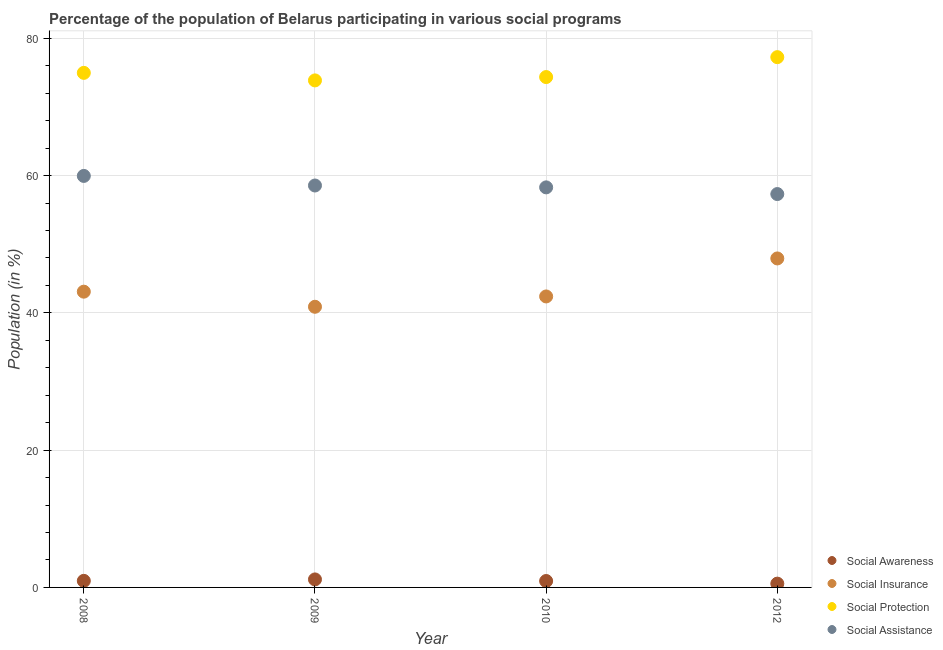What is the participation of population in social protection programs in 2009?
Keep it short and to the point. 73.86. Across all years, what is the maximum participation of population in social protection programs?
Keep it short and to the point. 77.25. Across all years, what is the minimum participation of population in social assistance programs?
Keep it short and to the point. 57.3. In which year was the participation of population in social assistance programs maximum?
Your answer should be very brief. 2008. What is the total participation of population in social protection programs in the graph?
Your answer should be very brief. 300.42. What is the difference between the participation of population in social protection programs in 2010 and that in 2012?
Offer a terse response. -2.9. What is the difference between the participation of population in social awareness programs in 2010 and the participation of population in social insurance programs in 2008?
Your answer should be very brief. -42.15. What is the average participation of population in social protection programs per year?
Offer a very short reply. 75.11. In the year 2009, what is the difference between the participation of population in social protection programs and participation of population in social insurance programs?
Ensure brevity in your answer.  32.98. What is the ratio of the participation of population in social protection programs in 2009 to that in 2012?
Offer a very short reply. 0.96. Is the participation of population in social insurance programs in 2008 less than that in 2010?
Give a very brief answer. No. What is the difference between the highest and the second highest participation of population in social protection programs?
Provide a short and direct response. 2.29. What is the difference between the highest and the lowest participation of population in social insurance programs?
Offer a terse response. 7.04. Is the sum of the participation of population in social protection programs in 2009 and 2012 greater than the maximum participation of population in social assistance programs across all years?
Offer a very short reply. Yes. Is it the case that in every year, the sum of the participation of population in social insurance programs and participation of population in social assistance programs is greater than the sum of participation of population in social awareness programs and participation of population in social protection programs?
Ensure brevity in your answer.  Yes. Is it the case that in every year, the sum of the participation of population in social awareness programs and participation of population in social insurance programs is greater than the participation of population in social protection programs?
Provide a succinct answer. No. Is the participation of population in social assistance programs strictly greater than the participation of population in social insurance programs over the years?
Your answer should be very brief. Yes. Is the participation of population in social insurance programs strictly less than the participation of population in social protection programs over the years?
Offer a very short reply. Yes. How many years are there in the graph?
Offer a terse response. 4. Are the values on the major ticks of Y-axis written in scientific E-notation?
Provide a succinct answer. No. Does the graph contain any zero values?
Offer a very short reply. No. Where does the legend appear in the graph?
Offer a very short reply. Bottom right. What is the title of the graph?
Provide a short and direct response. Percentage of the population of Belarus participating in various social programs . What is the Population (in %) in Social Awareness in 2008?
Provide a short and direct response. 0.96. What is the Population (in %) in Social Insurance in 2008?
Make the answer very short. 43.09. What is the Population (in %) in Social Protection in 2008?
Give a very brief answer. 74.96. What is the Population (in %) of Social Assistance in 2008?
Keep it short and to the point. 59.95. What is the Population (in %) in Social Awareness in 2009?
Make the answer very short. 1.17. What is the Population (in %) of Social Insurance in 2009?
Keep it short and to the point. 40.89. What is the Population (in %) in Social Protection in 2009?
Offer a very short reply. 73.86. What is the Population (in %) in Social Assistance in 2009?
Keep it short and to the point. 58.55. What is the Population (in %) of Social Awareness in 2010?
Ensure brevity in your answer.  0.93. What is the Population (in %) in Social Insurance in 2010?
Your response must be concise. 42.39. What is the Population (in %) in Social Protection in 2010?
Ensure brevity in your answer.  74.35. What is the Population (in %) of Social Assistance in 2010?
Provide a short and direct response. 58.28. What is the Population (in %) of Social Awareness in 2012?
Make the answer very short. 0.55. What is the Population (in %) in Social Insurance in 2012?
Give a very brief answer. 47.93. What is the Population (in %) in Social Protection in 2012?
Offer a terse response. 77.25. What is the Population (in %) of Social Assistance in 2012?
Offer a very short reply. 57.3. Across all years, what is the maximum Population (in %) in Social Awareness?
Keep it short and to the point. 1.17. Across all years, what is the maximum Population (in %) of Social Insurance?
Make the answer very short. 47.93. Across all years, what is the maximum Population (in %) in Social Protection?
Provide a short and direct response. 77.25. Across all years, what is the maximum Population (in %) in Social Assistance?
Ensure brevity in your answer.  59.95. Across all years, what is the minimum Population (in %) in Social Awareness?
Your answer should be very brief. 0.55. Across all years, what is the minimum Population (in %) of Social Insurance?
Keep it short and to the point. 40.89. Across all years, what is the minimum Population (in %) of Social Protection?
Make the answer very short. 73.86. Across all years, what is the minimum Population (in %) of Social Assistance?
Ensure brevity in your answer.  57.3. What is the total Population (in %) in Social Awareness in the graph?
Provide a succinct answer. 3.61. What is the total Population (in %) in Social Insurance in the graph?
Your answer should be compact. 174.29. What is the total Population (in %) of Social Protection in the graph?
Give a very brief answer. 300.42. What is the total Population (in %) in Social Assistance in the graph?
Give a very brief answer. 234.08. What is the difference between the Population (in %) in Social Awareness in 2008 and that in 2009?
Your answer should be compact. -0.21. What is the difference between the Population (in %) of Social Insurance in 2008 and that in 2009?
Your answer should be very brief. 2.2. What is the difference between the Population (in %) of Social Protection in 2008 and that in 2009?
Offer a very short reply. 1.1. What is the difference between the Population (in %) of Social Assistance in 2008 and that in 2009?
Keep it short and to the point. 1.4. What is the difference between the Population (in %) of Social Awareness in 2008 and that in 2010?
Provide a succinct answer. 0.02. What is the difference between the Population (in %) in Social Insurance in 2008 and that in 2010?
Make the answer very short. 0.7. What is the difference between the Population (in %) in Social Protection in 2008 and that in 2010?
Offer a terse response. 0.61. What is the difference between the Population (in %) in Social Assistance in 2008 and that in 2010?
Offer a terse response. 1.67. What is the difference between the Population (in %) of Social Awareness in 2008 and that in 2012?
Your answer should be compact. 0.4. What is the difference between the Population (in %) of Social Insurance in 2008 and that in 2012?
Offer a very short reply. -4.84. What is the difference between the Population (in %) in Social Protection in 2008 and that in 2012?
Give a very brief answer. -2.29. What is the difference between the Population (in %) in Social Assistance in 2008 and that in 2012?
Keep it short and to the point. 2.64. What is the difference between the Population (in %) in Social Awareness in 2009 and that in 2010?
Your answer should be compact. 0.23. What is the difference between the Population (in %) of Social Insurance in 2009 and that in 2010?
Your answer should be compact. -1.5. What is the difference between the Population (in %) in Social Protection in 2009 and that in 2010?
Provide a short and direct response. -0.49. What is the difference between the Population (in %) in Social Assistance in 2009 and that in 2010?
Ensure brevity in your answer.  0.27. What is the difference between the Population (in %) in Social Awareness in 2009 and that in 2012?
Make the answer very short. 0.61. What is the difference between the Population (in %) in Social Insurance in 2009 and that in 2012?
Your answer should be very brief. -7.04. What is the difference between the Population (in %) of Social Protection in 2009 and that in 2012?
Your answer should be very brief. -3.39. What is the difference between the Population (in %) in Social Assistance in 2009 and that in 2012?
Provide a succinct answer. 1.25. What is the difference between the Population (in %) in Social Awareness in 2010 and that in 2012?
Provide a succinct answer. 0.38. What is the difference between the Population (in %) in Social Insurance in 2010 and that in 2012?
Provide a succinct answer. -5.54. What is the difference between the Population (in %) in Social Protection in 2010 and that in 2012?
Your answer should be very brief. -2.9. What is the difference between the Population (in %) in Social Assistance in 2010 and that in 2012?
Give a very brief answer. 0.97. What is the difference between the Population (in %) of Social Awareness in 2008 and the Population (in %) of Social Insurance in 2009?
Your answer should be compact. -39.93. What is the difference between the Population (in %) of Social Awareness in 2008 and the Population (in %) of Social Protection in 2009?
Provide a succinct answer. -72.9. What is the difference between the Population (in %) of Social Awareness in 2008 and the Population (in %) of Social Assistance in 2009?
Your answer should be compact. -57.59. What is the difference between the Population (in %) in Social Insurance in 2008 and the Population (in %) in Social Protection in 2009?
Provide a short and direct response. -30.78. What is the difference between the Population (in %) in Social Insurance in 2008 and the Population (in %) in Social Assistance in 2009?
Offer a very short reply. -15.47. What is the difference between the Population (in %) in Social Protection in 2008 and the Population (in %) in Social Assistance in 2009?
Offer a very short reply. 16.41. What is the difference between the Population (in %) in Social Awareness in 2008 and the Population (in %) in Social Insurance in 2010?
Your answer should be compact. -41.43. What is the difference between the Population (in %) of Social Awareness in 2008 and the Population (in %) of Social Protection in 2010?
Make the answer very short. -73.39. What is the difference between the Population (in %) of Social Awareness in 2008 and the Population (in %) of Social Assistance in 2010?
Offer a terse response. -57.32. What is the difference between the Population (in %) in Social Insurance in 2008 and the Population (in %) in Social Protection in 2010?
Ensure brevity in your answer.  -31.26. What is the difference between the Population (in %) in Social Insurance in 2008 and the Population (in %) in Social Assistance in 2010?
Your answer should be compact. -15.19. What is the difference between the Population (in %) of Social Protection in 2008 and the Population (in %) of Social Assistance in 2010?
Ensure brevity in your answer.  16.68. What is the difference between the Population (in %) in Social Awareness in 2008 and the Population (in %) in Social Insurance in 2012?
Your answer should be very brief. -46.97. What is the difference between the Population (in %) of Social Awareness in 2008 and the Population (in %) of Social Protection in 2012?
Offer a very short reply. -76.29. What is the difference between the Population (in %) of Social Awareness in 2008 and the Population (in %) of Social Assistance in 2012?
Keep it short and to the point. -56.35. What is the difference between the Population (in %) in Social Insurance in 2008 and the Population (in %) in Social Protection in 2012?
Your answer should be compact. -34.16. What is the difference between the Population (in %) of Social Insurance in 2008 and the Population (in %) of Social Assistance in 2012?
Your answer should be very brief. -14.22. What is the difference between the Population (in %) of Social Protection in 2008 and the Population (in %) of Social Assistance in 2012?
Your answer should be compact. 17.66. What is the difference between the Population (in %) in Social Awareness in 2009 and the Population (in %) in Social Insurance in 2010?
Provide a short and direct response. -41.22. What is the difference between the Population (in %) in Social Awareness in 2009 and the Population (in %) in Social Protection in 2010?
Keep it short and to the point. -73.18. What is the difference between the Population (in %) of Social Awareness in 2009 and the Population (in %) of Social Assistance in 2010?
Ensure brevity in your answer.  -57.11. What is the difference between the Population (in %) in Social Insurance in 2009 and the Population (in %) in Social Protection in 2010?
Ensure brevity in your answer.  -33.47. What is the difference between the Population (in %) of Social Insurance in 2009 and the Population (in %) of Social Assistance in 2010?
Your answer should be very brief. -17.39. What is the difference between the Population (in %) in Social Protection in 2009 and the Population (in %) in Social Assistance in 2010?
Your answer should be very brief. 15.58. What is the difference between the Population (in %) in Social Awareness in 2009 and the Population (in %) in Social Insurance in 2012?
Provide a succinct answer. -46.76. What is the difference between the Population (in %) of Social Awareness in 2009 and the Population (in %) of Social Protection in 2012?
Your answer should be very brief. -76.08. What is the difference between the Population (in %) in Social Awareness in 2009 and the Population (in %) in Social Assistance in 2012?
Keep it short and to the point. -56.14. What is the difference between the Population (in %) of Social Insurance in 2009 and the Population (in %) of Social Protection in 2012?
Offer a terse response. -36.37. What is the difference between the Population (in %) of Social Insurance in 2009 and the Population (in %) of Social Assistance in 2012?
Your answer should be very brief. -16.42. What is the difference between the Population (in %) in Social Protection in 2009 and the Population (in %) in Social Assistance in 2012?
Provide a short and direct response. 16.56. What is the difference between the Population (in %) in Social Awareness in 2010 and the Population (in %) in Social Insurance in 2012?
Your answer should be compact. -46.99. What is the difference between the Population (in %) in Social Awareness in 2010 and the Population (in %) in Social Protection in 2012?
Give a very brief answer. -76.32. What is the difference between the Population (in %) in Social Awareness in 2010 and the Population (in %) in Social Assistance in 2012?
Make the answer very short. -56.37. What is the difference between the Population (in %) in Social Insurance in 2010 and the Population (in %) in Social Protection in 2012?
Provide a short and direct response. -34.86. What is the difference between the Population (in %) of Social Insurance in 2010 and the Population (in %) of Social Assistance in 2012?
Your answer should be compact. -14.92. What is the difference between the Population (in %) of Social Protection in 2010 and the Population (in %) of Social Assistance in 2012?
Keep it short and to the point. 17.05. What is the average Population (in %) of Social Awareness per year?
Give a very brief answer. 0.9. What is the average Population (in %) of Social Insurance per year?
Provide a succinct answer. 43.57. What is the average Population (in %) of Social Protection per year?
Offer a very short reply. 75.11. What is the average Population (in %) in Social Assistance per year?
Ensure brevity in your answer.  58.52. In the year 2008, what is the difference between the Population (in %) of Social Awareness and Population (in %) of Social Insurance?
Your response must be concise. -42.13. In the year 2008, what is the difference between the Population (in %) of Social Awareness and Population (in %) of Social Protection?
Your answer should be very brief. -74. In the year 2008, what is the difference between the Population (in %) of Social Awareness and Population (in %) of Social Assistance?
Your response must be concise. -58.99. In the year 2008, what is the difference between the Population (in %) in Social Insurance and Population (in %) in Social Protection?
Your answer should be very brief. -31.88. In the year 2008, what is the difference between the Population (in %) in Social Insurance and Population (in %) in Social Assistance?
Make the answer very short. -16.86. In the year 2008, what is the difference between the Population (in %) in Social Protection and Population (in %) in Social Assistance?
Make the answer very short. 15.01. In the year 2009, what is the difference between the Population (in %) in Social Awareness and Population (in %) in Social Insurance?
Ensure brevity in your answer.  -39.72. In the year 2009, what is the difference between the Population (in %) of Social Awareness and Population (in %) of Social Protection?
Ensure brevity in your answer.  -72.7. In the year 2009, what is the difference between the Population (in %) in Social Awareness and Population (in %) in Social Assistance?
Your answer should be very brief. -57.39. In the year 2009, what is the difference between the Population (in %) of Social Insurance and Population (in %) of Social Protection?
Offer a very short reply. -32.98. In the year 2009, what is the difference between the Population (in %) of Social Insurance and Population (in %) of Social Assistance?
Offer a terse response. -17.67. In the year 2009, what is the difference between the Population (in %) of Social Protection and Population (in %) of Social Assistance?
Make the answer very short. 15.31. In the year 2010, what is the difference between the Population (in %) of Social Awareness and Population (in %) of Social Insurance?
Your response must be concise. -41.46. In the year 2010, what is the difference between the Population (in %) in Social Awareness and Population (in %) in Social Protection?
Make the answer very short. -73.42. In the year 2010, what is the difference between the Population (in %) of Social Awareness and Population (in %) of Social Assistance?
Your answer should be very brief. -57.34. In the year 2010, what is the difference between the Population (in %) in Social Insurance and Population (in %) in Social Protection?
Give a very brief answer. -31.96. In the year 2010, what is the difference between the Population (in %) of Social Insurance and Population (in %) of Social Assistance?
Offer a terse response. -15.89. In the year 2010, what is the difference between the Population (in %) in Social Protection and Population (in %) in Social Assistance?
Make the answer very short. 16.07. In the year 2012, what is the difference between the Population (in %) in Social Awareness and Population (in %) in Social Insurance?
Your answer should be compact. -47.37. In the year 2012, what is the difference between the Population (in %) of Social Awareness and Population (in %) of Social Protection?
Provide a short and direct response. -76.7. In the year 2012, what is the difference between the Population (in %) in Social Awareness and Population (in %) in Social Assistance?
Keep it short and to the point. -56.75. In the year 2012, what is the difference between the Population (in %) of Social Insurance and Population (in %) of Social Protection?
Your answer should be very brief. -29.32. In the year 2012, what is the difference between the Population (in %) in Social Insurance and Population (in %) in Social Assistance?
Make the answer very short. -9.38. In the year 2012, what is the difference between the Population (in %) in Social Protection and Population (in %) in Social Assistance?
Keep it short and to the point. 19.95. What is the ratio of the Population (in %) of Social Awareness in 2008 to that in 2009?
Provide a short and direct response. 0.82. What is the ratio of the Population (in %) of Social Insurance in 2008 to that in 2009?
Give a very brief answer. 1.05. What is the ratio of the Population (in %) of Social Protection in 2008 to that in 2009?
Ensure brevity in your answer.  1.01. What is the ratio of the Population (in %) in Social Assistance in 2008 to that in 2009?
Your answer should be very brief. 1.02. What is the ratio of the Population (in %) in Social Awareness in 2008 to that in 2010?
Your answer should be very brief. 1.02. What is the ratio of the Population (in %) in Social Insurance in 2008 to that in 2010?
Keep it short and to the point. 1.02. What is the ratio of the Population (in %) of Social Protection in 2008 to that in 2010?
Provide a succinct answer. 1.01. What is the ratio of the Population (in %) in Social Assistance in 2008 to that in 2010?
Your answer should be compact. 1.03. What is the ratio of the Population (in %) of Social Awareness in 2008 to that in 2012?
Give a very brief answer. 1.73. What is the ratio of the Population (in %) of Social Insurance in 2008 to that in 2012?
Give a very brief answer. 0.9. What is the ratio of the Population (in %) in Social Protection in 2008 to that in 2012?
Provide a succinct answer. 0.97. What is the ratio of the Population (in %) of Social Assistance in 2008 to that in 2012?
Ensure brevity in your answer.  1.05. What is the ratio of the Population (in %) of Social Awareness in 2009 to that in 2010?
Your answer should be compact. 1.25. What is the ratio of the Population (in %) of Social Insurance in 2009 to that in 2010?
Ensure brevity in your answer.  0.96. What is the ratio of the Population (in %) in Social Protection in 2009 to that in 2010?
Your answer should be compact. 0.99. What is the ratio of the Population (in %) in Social Assistance in 2009 to that in 2010?
Your answer should be compact. 1. What is the ratio of the Population (in %) in Social Awareness in 2009 to that in 2012?
Keep it short and to the point. 2.11. What is the ratio of the Population (in %) of Social Insurance in 2009 to that in 2012?
Ensure brevity in your answer.  0.85. What is the ratio of the Population (in %) of Social Protection in 2009 to that in 2012?
Keep it short and to the point. 0.96. What is the ratio of the Population (in %) of Social Assistance in 2009 to that in 2012?
Your answer should be compact. 1.02. What is the ratio of the Population (in %) in Social Awareness in 2010 to that in 2012?
Give a very brief answer. 1.69. What is the ratio of the Population (in %) in Social Insurance in 2010 to that in 2012?
Your answer should be very brief. 0.88. What is the ratio of the Population (in %) of Social Protection in 2010 to that in 2012?
Your response must be concise. 0.96. What is the difference between the highest and the second highest Population (in %) in Social Awareness?
Provide a succinct answer. 0.21. What is the difference between the highest and the second highest Population (in %) in Social Insurance?
Give a very brief answer. 4.84. What is the difference between the highest and the second highest Population (in %) in Social Protection?
Your answer should be very brief. 2.29. What is the difference between the highest and the second highest Population (in %) in Social Assistance?
Your answer should be very brief. 1.4. What is the difference between the highest and the lowest Population (in %) of Social Awareness?
Keep it short and to the point. 0.61. What is the difference between the highest and the lowest Population (in %) of Social Insurance?
Keep it short and to the point. 7.04. What is the difference between the highest and the lowest Population (in %) of Social Protection?
Give a very brief answer. 3.39. What is the difference between the highest and the lowest Population (in %) of Social Assistance?
Make the answer very short. 2.64. 